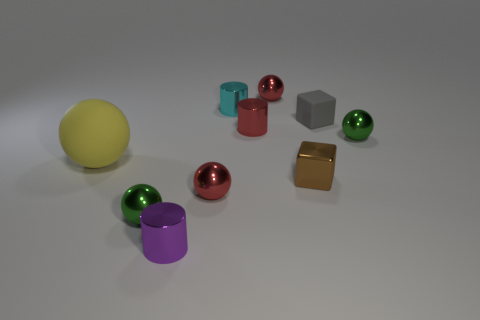What is the color of the big rubber thing?
Ensure brevity in your answer.  Yellow. What is the shape of the red metal thing that is in front of the tiny green metal sphere that is behind the tiny block in front of the gray thing?
Your answer should be compact. Sphere. The tiny ball that is behind the tiny metallic block and on the left side of the small brown metallic thing is made of what material?
Your answer should be compact. Metal. There is a tiny green shiny object behind the green sphere that is left of the cyan shiny cylinder; what shape is it?
Your response must be concise. Sphere. Is there any other thing of the same color as the large object?
Your response must be concise. No. There is a yellow thing; does it have the same size as the green metal ball to the left of the purple shiny object?
Offer a very short reply. No. What number of tiny objects are cyan objects or yellow spheres?
Provide a succinct answer. 1. Are there more big yellow objects than green metallic things?
Make the answer very short. No. There is a green thing to the right of the tiny red sphere that is to the left of the cyan cylinder; what number of tiny blocks are in front of it?
Provide a short and direct response. 1. What is the shape of the large matte object?
Offer a terse response. Sphere. 